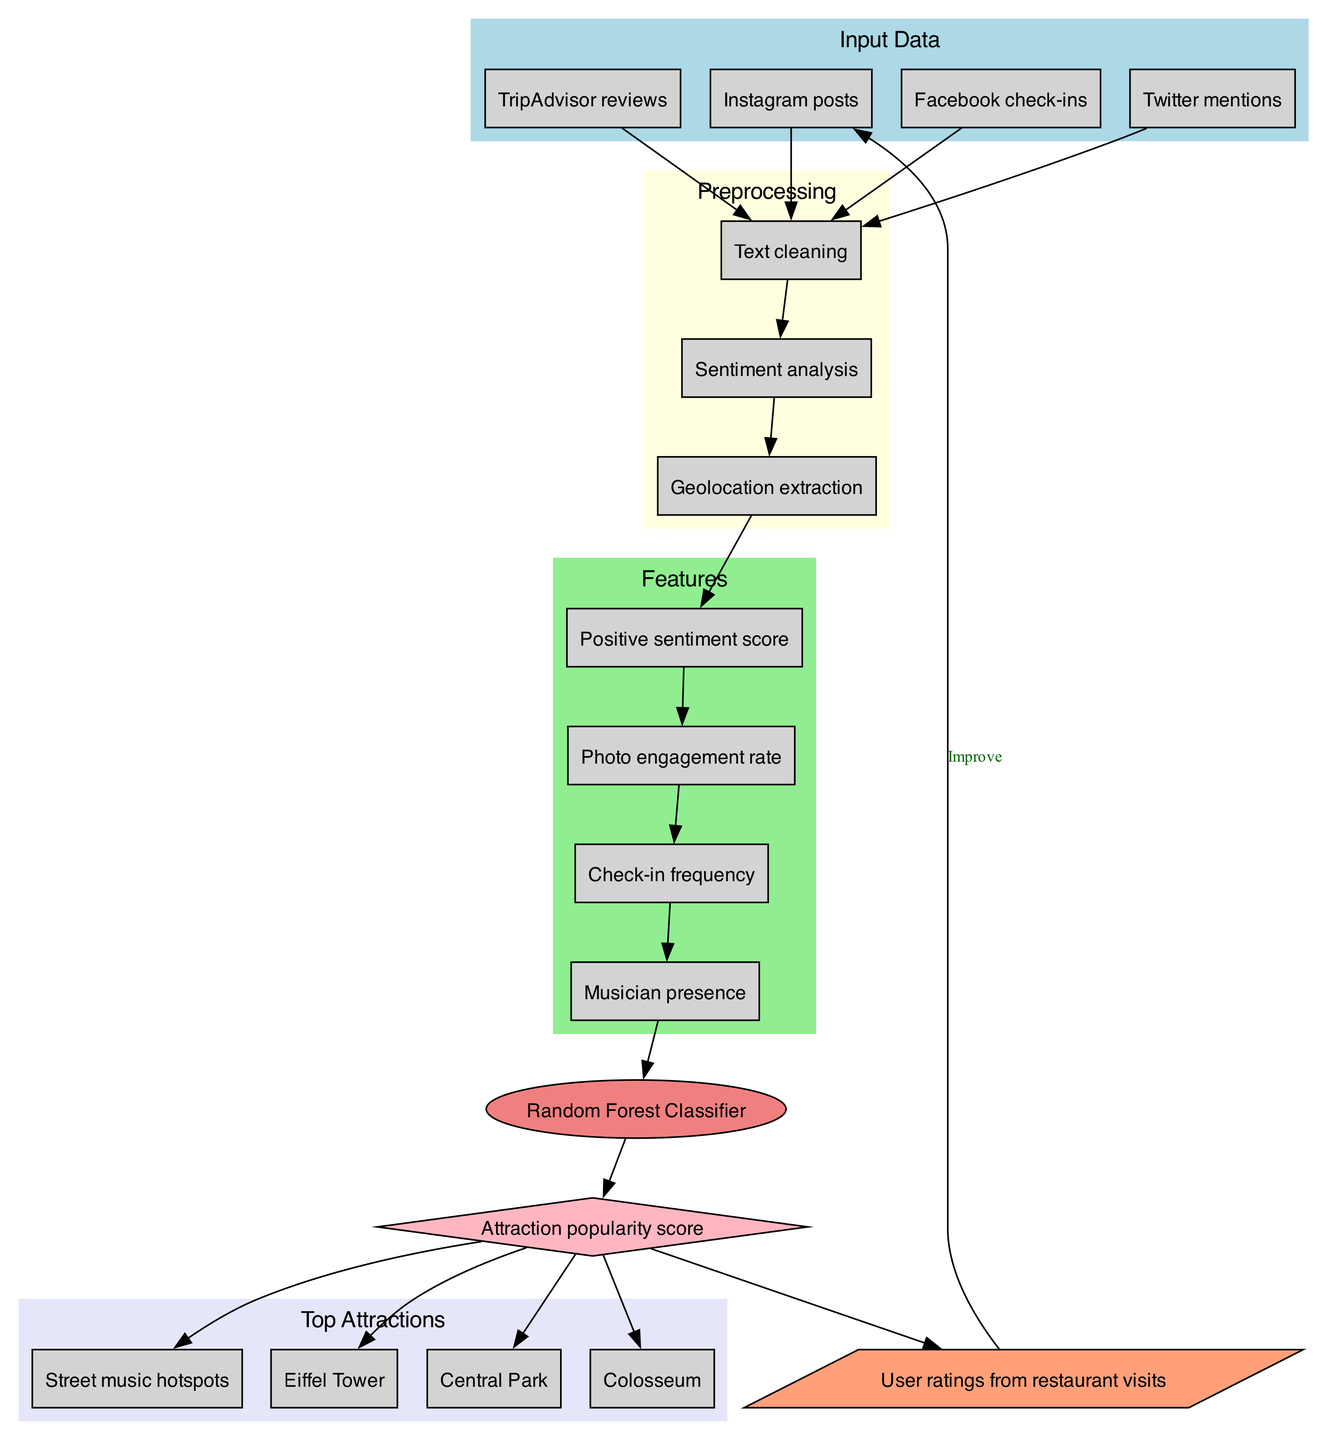What are the types of input data? The input data is listed in the "Input Data" section of the diagram, which includes Instagram posts, TripAdvisor reviews, Facebook check-ins, and Twitter mentions.
Answer: Instagram posts, TripAdvisor reviews, Facebook check-ins, Twitter mentions How many preprocessing steps are there? The diagram indicates four distinct preprocessing steps: Text cleaning, Sentiment analysis, and Geolocation extraction, so we count each step shown under the "Preprocessing" section.
Answer: 3 What model is used in this system? The model is explicitly labeled in the diagram and is shown as a node with the designation "Random Forest Classifier".
Answer: Random Forest Classifier What is the output of the model? The output node in the diagram specifies "Attraction popularity score" as the result of the model's processing.
Answer: Attraction popularity score Which attractions are listed as the top attractions? The top attractions are shown in a dedicated section of the diagram, enumerating specific locations and activities. The listed attractions are Eiffel Tower, Central Park, Colosseum, and Street music hotspots.
Answer: Eiffel Tower, Central Park, Colosseum, Street music hotspots How does feedback influence the input? The feedback loop connects back to the "input_0" node with a label "Improve", indicating that user ratings from restaurant visits are used to refine or enhance the model's input data.
Answer: Improve Which preprocessing step comes after sentiment analysis? By tracing the connections in the "Preprocessing" section, we see that "Geolocation extraction" follows directly after "Sentiment analysis".
Answer: Geolocation extraction How many features are extracted from the preprocessing steps? Counting the features listed in the "Features" section in the diagram, we see there are four features extracted: Positive sentiment score, Photo engagement rate, Check-in frequency, and Musician presence.
Answer: 4 What role does sentiment analysis play in the diagram? Sentiment analysis is listed within the preprocessing steps and influences the sentiment score feature, which contributes to the model's prediction of attraction popularity, demonstrated by how it connects to the features and ultimately the model.
Answer: Contributes to features 